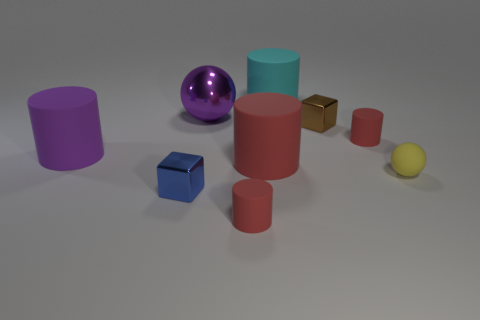Subtract all red cylinders. How many were subtracted if there are1red cylinders left? 2 Subtract all small red cylinders. How many cylinders are left? 3 Subtract all purple spheres. How many red cylinders are left? 3 Add 1 red matte cylinders. How many objects exist? 10 Subtract all red cylinders. How many cylinders are left? 2 Subtract all cylinders. How many objects are left? 4 Subtract all small matte cylinders. Subtract all red matte cylinders. How many objects are left? 4 Add 7 cyan rubber things. How many cyan rubber things are left? 8 Add 7 big yellow things. How many big yellow things exist? 7 Subtract 0 gray cubes. How many objects are left? 9 